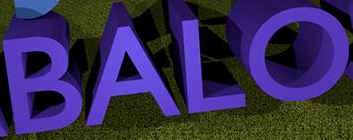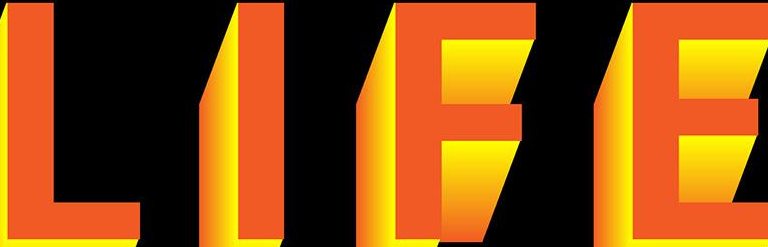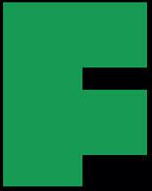Read the text content from these images in order, separated by a semicolon. BALO; LIFE; F 